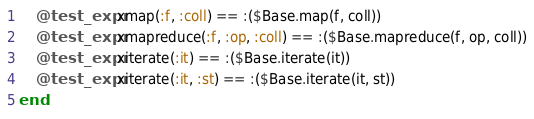<code> <loc_0><loc_0><loc_500><loc_500><_Julia_>    @test_expr xmap(:f, :coll) == :($Base.map(f, coll))
    @test_expr xmapreduce(:f, :op, :coll) == :($Base.mapreduce(f, op, coll))
    @test_expr xiterate(:it) == :($Base.iterate(it))
    @test_expr xiterate(:it, :st) == :($Base.iterate(it, st))        
end
</code> 